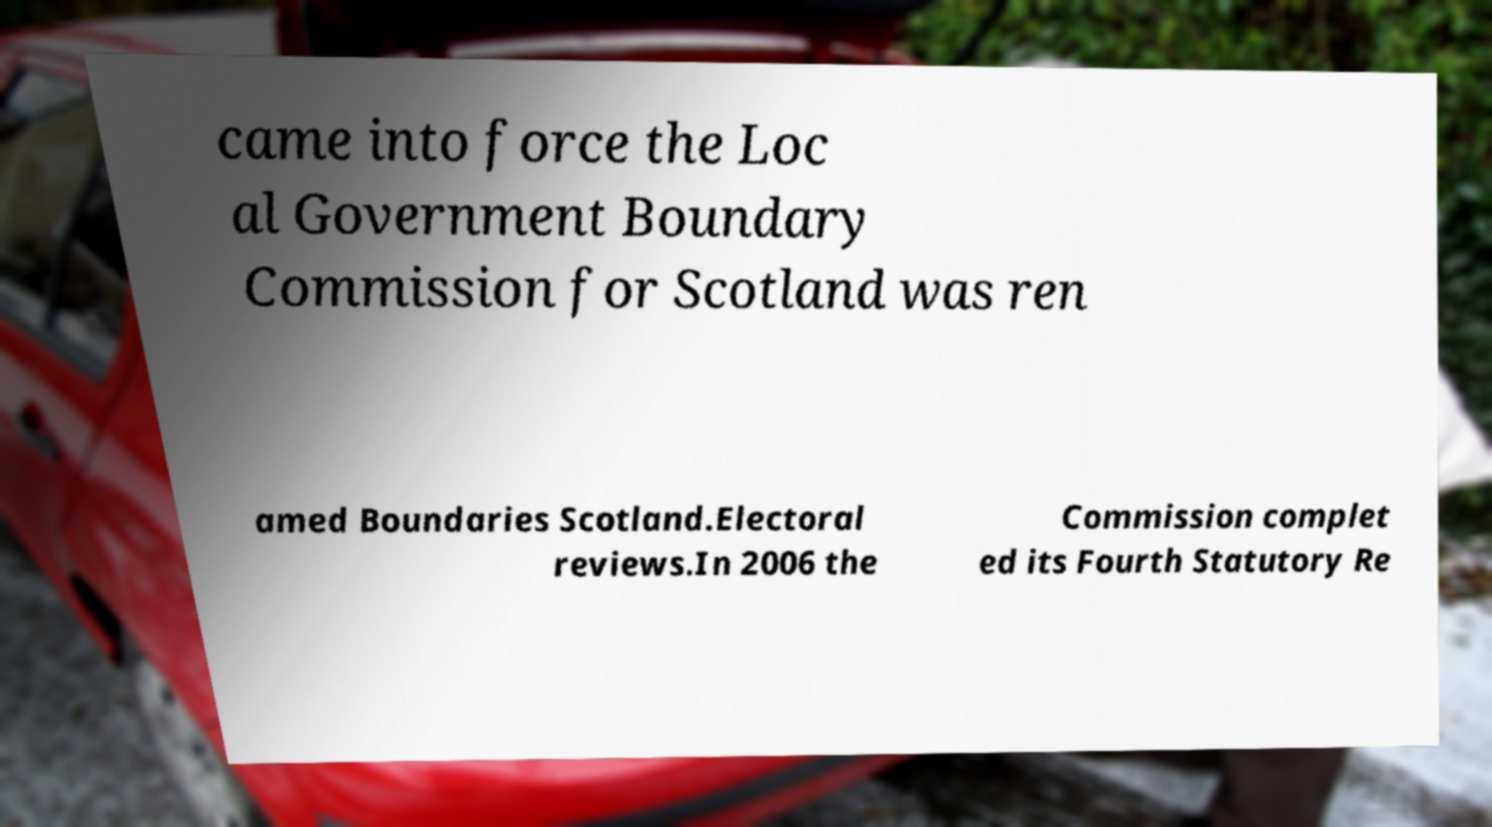Please read and relay the text visible in this image. What does it say? came into force the Loc al Government Boundary Commission for Scotland was ren amed Boundaries Scotland.Electoral reviews.In 2006 the Commission complet ed its Fourth Statutory Re 